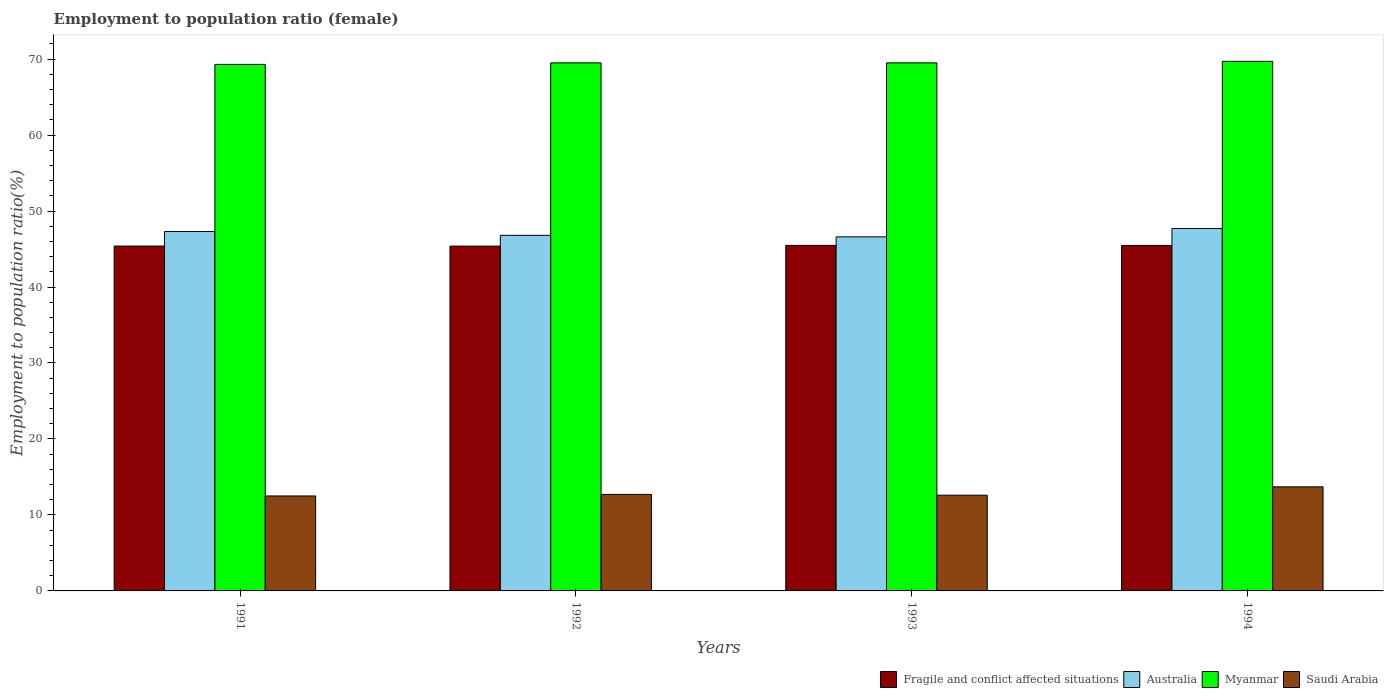How many different coloured bars are there?
Keep it short and to the point. 4. How many bars are there on the 2nd tick from the right?
Provide a succinct answer. 4. What is the label of the 2nd group of bars from the left?
Offer a terse response. 1992. What is the employment to population ratio in Australia in 1992?
Provide a succinct answer. 46.8. Across all years, what is the maximum employment to population ratio in Fragile and conflict affected situations?
Make the answer very short. 45.48. In which year was the employment to population ratio in Myanmar maximum?
Ensure brevity in your answer.  1994. In which year was the employment to population ratio in Fragile and conflict affected situations minimum?
Offer a very short reply. 1992. What is the total employment to population ratio in Australia in the graph?
Keep it short and to the point. 188.4. What is the difference between the employment to population ratio in Australia in 1991 and that in 1994?
Your response must be concise. -0.4. What is the difference between the employment to population ratio in Fragile and conflict affected situations in 1991 and the employment to population ratio in Saudi Arabia in 1994?
Your answer should be very brief. 31.69. What is the average employment to population ratio in Fragile and conflict affected situations per year?
Your answer should be very brief. 45.43. In the year 1992, what is the difference between the employment to population ratio in Myanmar and employment to population ratio in Australia?
Offer a terse response. 22.7. What is the ratio of the employment to population ratio in Australia in 1992 to that in 1993?
Offer a very short reply. 1. What is the difference between the highest and the second highest employment to population ratio in Australia?
Keep it short and to the point. 0.4. What is the difference between the highest and the lowest employment to population ratio in Saudi Arabia?
Provide a succinct answer. 1.2. Is the sum of the employment to population ratio in Saudi Arabia in 1993 and 1994 greater than the maximum employment to population ratio in Myanmar across all years?
Your answer should be very brief. No. Is it the case that in every year, the sum of the employment to population ratio in Australia and employment to population ratio in Fragile and conflict affected situations is greater than the sum of employment to population ratio in Saudi Arabia and employment to population ratio in Myanmar?
Make the answer very short. No. What does the 2nd bar from the left in 1991 represents?
Provide a short and direct response. Australia. What does the 2nd bar from the right in 1991 represents?
Your answer should be compact. Myanmar. Are all the bars in the graph horizontal?
Your answer should be very brief. No. Are the values on the major ticks of Y-axis written in scientific E-notation?
Provide a succinct answer. No. How many legend labels are there?
Your answer should be compact. 4. How are the legend labels stacked?
Make the answer very short. Horizontal. What is the title of the graph?
Your answer should be compact. Employment to population ratio (female). What is the label or title of the Y-axis?
Offer a very short reply. Employment to population ratio(%). What is the Employment to population ratio(%) of Fragile and conflict affected situations in 1991?
Offer a terse response. 45.39. What is the Employment to population ratio(%) of Australia in 1991?
Give a very brief answer. 47.3. What is the Employment to population ratio(%) in Myanmar in 1991?
Give a very brief answer. 69.3. What is the Employment to population ratio(%) in Fragile and conflict affected situations in 1992?
Offer a terse response. 45.38. What is the Employment to population ratio(%) in Australia in 1992?
Ensure brevity in your answer.  46.8. What is the Employment to population ratio(%) in Myanmar in 1992?
Make the answer very short. 69.5. What is the Employment to population ratio(%) of Saudi Arabia in 1992?
Your answer should be very brief. 12.7. What is the Employment to population ratio(%) in Fragile and conflict affected situations in 1993?
Your answer should be compact. 45.48. What is the Employment to population ratio(%) in Australia in 1993?
Give a very brief answer. 46.6. What is the Employment to population ratio(%) in Myanmar in 1993?
Your response must be concise. 69.5. What is the Employment to population ratio(%) of Saudi Arabia in 1993?
Make the answer very short. 12.6. What is the Employment to population ratio(%) of Fragile and conflict affected situations in 1994?
Make the answer very short. 45.47. What is the Employment to population ratio(%) of Australia in 1994?
Ensure brevity in your answer.  47.7. What is the Employment to population ratio(%) in Myanmar in 1994?
Your answer should be compact. 69.7. What is the Employment to population ratio(%) of Saudi Arabia in 1994?
Your answer should be compact. 13.7. Across all years, what is the maximum Employment to population ratio(%) in Fragile and conflict affected situations?
Keep it short and to the point. 45.48. Across all years, what is the maximum Employment to population ratio(%) in Australia?
Provide a short and direct response. 47.7. Across all years, what is the maximum Employment to population ratio(%) in Myanmar?
Ensure brevity in your answer.  69.7. Across all years, what is the maximum Employment to population ratio(%) of Saudi Arabia?
Give a very brief answer. 13.7. Across all years, what is the minimum Employment to population ratio(%) of Fragile and conflict affected situations?
Offer a very short reply. 45.38. Across all years, what is the minimum Employment to population ratio(%) of Australia?
Offer a terse response. 46.6. Across all years, what is the minimum Employment to population ratio(%) of Myanmar?
Your answer should be very brief. 69.3. What is the total Employment to population ratio(%) in Fragile and conflict affected situations in the graph?
Provide a succinct answer. 181.72. What is the total Employment to population ratio(%) of Australia in the graph?
Ensure brevity in your answer.  188.4. What is the total Employment to population ratio(%) in Myanmar in the graph?
Make the answer very short. 278. What is the total Employment to population ratio(%) in Saudi Arabia in the graph?
Offer a terse response. 51.5. What is the difference between the Employment to population ratio(%) in Fragile and conflict affected situations in 1991 and that in 1992?
Make the answer very short. 0.01. What is the difference between the Employment to population ratio(%) of Saudi Arabia in 1991 and that in 1992?
Keep it short and to the point. -0.2. What is the difference between the Employment to population ratio(%) in Fragile and conflict affected situations in 1991 and that in 1993?
Make the answer very short. -0.08. What is the difference between the Employment to population ratio(%) in Myanmar in 1991 and that in 1993?
Your answer should be very brief. -0.2. What is the difference between the Employment to population ratio(%) of Fragile and conflict affected situations in 1991 and that in 1994?
Offer a terse response. -0.08. What is the difference between the Employment to population ratio(%) in Australia in 1991 and that in 1994?
Offer a very short reply. -0.4. What is the difference between the Employment to population ratio(%) of Myanmar in 1991 and that in 1994?
Give a very brief answer. -0.4. What is the difference between the Employment to population ratio(%) in Fragile and conflict affected situations in 1992 and that in 1993?
Provide a succinct answer. -0.09. What is the difference between the Employment to population ratio(%) in Australia in 1992 and that in 1993?
Ensure brevity in your answer.  0.2. What is the difference between the Employment to population ratio(%) in Saudi Arabia in 1992 and that in 1993?
Your response must be concise. 0.1. What is the difference between the Employment to population ratio(%) of Fragile and conflict affected situations in 1992 and that in 1994?
Make the answer very short. -0.09. What is the difference between the Employment to population ratio(%) of Australia in 1992 and that in 1994?
Make the answer very short. -0.9. What is the difference between the Employment to population ratio(%) in Myanmar in 1992 and that in 1994?
Your answer should be very brief. -0.2. What is the difference between the Employment to population ratio(%) of Saudi Arabia in 1992 and that in 1994?
Offer a very short reply. -1. What is the difference between the Employment to population ratio(%) in Fragile and conflict affected situations in 1993 and that in 1994?
Provide a succinct answer. 0.01. What is the difference between the Employment to population ratio(%) of Australia in 1993 and that in 1994?
Offer a very short reply. -1.1. What is the difference between the Employment to population ratio(%) of Fragile and conflict affected situations in 1991 and the Employment to population ratio(%) of Australia in 1992?
Make the answer very short. -1.41. What is the difference between the Employment to population ratio(%) of Fragile and conflict affected situations in 1991 and the Employment to population ratio(%) of Myanmar in 1992?
Make the answer very short. -24.11. What is the difference between the Employment to population ratio(%) of Fragile and conflict affected situations in 1991 and the Employment to population ratio(%) of Saudi Arabia in 1992?
Your response must be concise. 32.69. What is the difference between the Employment to population ratio(%) of Australia in 1991 and the Employment to population ratio(%) of Myanmar in 1992?
Provide a succinct answer. -22.2. What is the difference between the Employment to population ratio(%) of Australia in 1991 and the Employment to population ratio(%) of Saudi Arabia in 1992?
Provide a succinct answer. 34.6. What is the difference between the Employment to population ratio(%) of Myanmar in 1991 and the Employment to population ratio(%) of Saudi Arabia in 1992?
Provide a succinct answer. 56.6. What is the difference between the Employment to population ratio(%) of Fragile and conflict affected situations in 1991 and the Employment to population ratio(%) of Australia in 1993?
Provide a short and direct response. -1.21. What is the difference between the Employment to population ratio(%) of Fragile and conflict affected situations in 1991 and the Employment to population ratio(%) of Myanmar in 1993?
Offer a terse response. -24.11. What is the difference between the Employment to population ratio(%) in Fragile and conflict affected situations in 1991 and the Employment to population ratio(%) in Saudi Arabia in 1993?
Your answer should be compact. 32.79. What is the difference between the Employment to population ratio(%) in Australia in 1991 and the Employment to population ratio(%) in Myanmar in 1993?
Your answer should be compact. -22.2. What is the difference between the Employment to population ratio(%) of Australia in 1991 and the Employment to population ratio(%) of Saudi Arabia in 1993?
Offer a terse response. 34.7. What is the difference between the Employment to population ratio(%) in Myanmar in 1991 and the Employment to population ratio(%) in Saudi Arabia in 1993?
Your answer should be very brief. 56.7. What is the difference between the Employment to population ratio(%) in Fragile and conflict affected situations in 1991 and the Employment to population ratio(%) in Australia in 1994?
Your answer should be compact. -2.31. What is the difference between the Employment to population ratio(%) of Fragile and conflict affected situations in 1991 and the Employment to population ratio(%) of Myanmar in 1994?
Make the answer very short. -24.31. What is the difference between the Employment to population ratio(%) in Fragile and conflict affected situations in 1991 and the Employment to population ratio(%) in Saudi Arabia in 1994?
Offer a very short reply. 31.69. What is the difference between the Employment to population ratio(%) of Australia in 1991 and the Employment to population ratio(%) of Myanmar in 1994?
Provide a succinct answer. -22.4. What is the difference between the Employment to population ratio(%) in Australia in 1991 and the Employment to population ratio(%) in Saudi Arabia in 1994?
Keep it short and to the point. 33.6. What is the difference between the Employment to population ratio(%) of Myanmar in 1991 and the Employment to population ratio(%) of Saudi Arabia in 1994?
Provide a succinct answer. 55.6. What is the difference between the Employment to population ratio(%) in Fragile and conflict affected situations in 1992 and the Employment to population ratio(%) in Australia in 1993?
Provide a short and direct response. -1.22. What is the difference between the Employment to population ratio(%) in Fragile and conflict affected situations in 1992 and the Employment to population ratio(%) in Myanmar in 1993?
Give a very brief answer. -24.12. What is the difference between the Employment to population ratio(%) in Fragile and conflict affected situations in 1992 and the Employment to population ratio(%) in Saudi Arabia in 1993?
Your answer should be very brief. 32.78. What is the difference between the Employment to population ratio(%) of Australia in 1992 and the Employment to population ratio(%) of Myanmar in 1993?
Make the answer very short. -22.7. What is the difference between the Employment to population ratio(%) in Australia in 1992 and the Employment to population ratio(%) in Saudi Arabia in 1993?
Give a very brief answer. 34.2. What is the difference between the Employment to population ratio(%) in Myanmar in 1992 and the Employment to population ratio(%) in Saudi Arabia in 1993?
Provide a succinct answer. 56.9. What is the difference between the Employment to population ratio(%) of Fragile and conflict affected situations in 1992 and the Employment to population ratio(%) of Australia in 1994?
Make the answer very short. -2.32. What is the difference between the Employment to population ratio(%) in Fragile and conflict affected situations in 1992 and the Employment to population ratio(%) in Myanmar in 1994?
Provide a succinct answer. -24.32. What is the difference between the Employment to population ratio(%) of Fragile and conflict affected situations in 1992 and the Employment to population ratio(%) of Saudi Arabia in 1994?
Give a very brief answer. 31.68. What is the difference between the Employment to population ratio(%) in Australia in 1992 and the Employment to population ratio(%) in Myanmar in 1994?
Your answer should be very brief. -22.9. What is the difference between the Employment to population ratio(%) in Australia in 1992 and the Employment to population ratio(%) in Saudi Arabia in 1994?
Keep it short and to the point. 33.1. What is the difference between the Employment to population ratio(%) in Myanmar in 1992 and the Employment to population ratio(%) in Saudi Arabia in 1994?
Give a very brief answer. 55.8. What is the difference between the Employment to population ratio(%) of Fragile and conflict affected situations in 1993 and the Employment to population ratio(%) of Australia in 1994?
Offer a very short reply. -2.23. What is the difference between the Employment to population ratio(%) of Fragile and conflict affected situations in 1993 and the Employment to population ratio(%) of Myanmar in 1994?
Offer a terse response. -24.23. What is the difference between the Employment to population ratio(%) of Fragile and conflict affected situations in 1993 and the Employment to population ratio(%) of Saudi Arabia in 1994?
Your response must be concise. 31.77. What is the difference between the Employment to population ratio(%) of Australia in 1993 and the Employment to population ratio(%) of Myanmar in 1994?
Provide a succinct answer. -23.1. What is the difference between the Employment to population ratio(%) in Australia in 1993 and the Employment to population ratio(%) in Saudi Arabia in 1994?
Your answer should be compact. 32.9. What is the difference between the Employment to population ratio(%) in Myanmar in 1993 and the Employment to population ratio(%) in Saudi Arabia in 1994?
Make the answer very short. 55.8. What is the average Employment to population ratio(%) of Fragile and conflict affected situations per year?
Provide a succinct answer. 45.43. What is the average Employment to population ratio(%) of Australia per year?
Keep it short and to the point. 47.1. What is the average Employment to population ratio(%) in Myanmar per year?
Your answer should be very brief. 69.5. What is the average Employment to population ratio(%) in Saudi Arabia per year?
Offer a very short reply. 12.88. In the year 1991, what is the difference between the Employment to population ratio(%) of Fragile and conflict affected situations and Employment to population ratio(%) of Australia?
Your response must be concise. -1.91. In the year 1991, what is the difference between the Employment to population ratio(%) in Fragile and conflict affected situations and Employment to population ratio(%) in Myanmar?
Offer a very short reply. -23.91. In the year 1991, what is the difference between the Employment to population ratio(%) of Fragile and conflict affected situations and Employment to population ratio(%) of Saudi Arabia?
Offer a terse response. 32.89. In the year 1991, what is the difference between the Employment to population ratio(%) in Australia and Employment to population ratio(%) in Myanmar?
Your answer should be compact. -22. In the year 1991, what is the difference between the Employment to population ratio(%) in Australia and Employment to population ratio(%) in Saudi Arabia?
Your response must be concise. 34.8. In the year 1991, what is the difference between the Employment to population ratio(%) of Myanmar and Employment to population ratio(%) of Saudi Arabia?
Your answer should be compact. 56.8. In the year 1992, what is the difference between the Employment to population ratio(%) in Fragile and conflict affected situations and Employment to population ratio(%) in Australia?
Your response must be concise. -1.42. In the year 1992, what is the difference between the Employment to population ratio(%) of Fragile and conflict affected situations and Employment to population ratio(%) of Myanmar?
Keep it short and to the point. -24.12. In the year 1992, what is the difference between the Employment to population ratio(%) of Fragile and conflict affected situations and Employment to population ratio(%) of Saudi Arabia?
Provide a succinct answer. 32.68. In the year 1992, what is the difference between the Employment to population ratio(%) of Australia and Employment to population ratio(%) of Myanmar?
Your answer should be compact. -22.7. In the year 1992, what is the difference between the Employment to population ratio(%) in Australia and Employment to population ratio(%) in Saudi Arabia?
Give a very brief answer. 34.1. In the year 1992, what is the difference between the Employment to population ratio(%) in Myanmar and Employment to population ratio(%) in Saudi Arabia?
Offer a terse response. 56.8. In the year 1993, what is the difference between the Employment to population ratio(%) in Fragile and conflict affected situations and Employment to population ratio(%) in Australia?
Provide a short and direct response. -1.12. In the year 1993, what is the difference between the Employment to population ratio(%) in Fragile and conflict affected situations and Employment to population ratio(%) in Myanmar?
Offer a terse response. -24.02. In the year 1993, what is the difference between the Employment to population ratio(%) of Fragile and conflict affected situations and Employment to population ratio(%) of Saudi Arabia?
Give a very brief answer. 32.88. In the year 1993, what is the difference between the Employment to population ratio(%) in Australia and Employment to population ratio(%) in Myanmar?
Your answer should be very brief. -22.9. In the year 1993, what is the difference between the Employment to population ratio(%) of Australia and Employment to population ratio(%) of Saudi Arabia?
Offer a very short reply. 34. In the year 1993, what is the difference between the Employment to population ratio(%) of Myanmar and Employment to population ratio(%) of Saudi Arabia?
Offer a very short reply. 56.9. In the year 1994, what is the difference between the Employment to population ratio(%) in Fragile and conflict affected situations and Employment to population ratio(%) in Australia?
Your answer should be very brief. -2.23. In the year 1994, what is the difference between the Employment to population ratio(%) in Fragile and conflict affected situations and Employment to population ratio(%) in Myanmar?
Your answer should be very brief. -24.23. In the year 1994, what is the difference between the Employment to population ratio(%) of Fragile and conflict affected situations and Employment to population ratio(%) of Saudi Arabia?
Keep it short and to the point. 31.77. In the year 1994, what is the difference between the Employment to population ratio(%) of Australia and Employment to population ratio(%) of Myanmar?
Offer a terse response. -22. In the year 1994, what is the difference between the Employment to population ratio(%) in Myanmar and Employment to population ratio(%) in Saudi Arabia?
Offer a terse response. 56. What is the ratio of the Employment to population ratio(%) in Fragile and conflict affected situations in 1991 to that in 1992?
Keep it short and to the point. 1. What is the ratio of the Employment to population ratio(%) of Australia in 1991 to that in 1992?
Your answer should be very brief. 1.01. What is the ratio of the Employment to population ratio(%) of Saudi Arabia in 1991 to that in 1992?
Offer a very short reply. 0.98. What is the ratio of the Employment to population ratio(%) in Fragile and conflict affected situations in 1991 to that in 1993?
Ensure brevity in your answer.  1. What is the ratio of the Employment to population ratio(%) in Saudi Arabia in 1991 to that in 1993?
Give a very brief answer. 0.99. What is the ratio of the Employment to population ratio(%) of Fragile and conflict affected situations in 1991 to that in 1994?
Keep it short and to the point. 1. What is the ratio of the Employment to population ratio(%) of Australia in 1991 to that in 1994?
Your answer should be very brief. 0.99. What is the ratio of the Employment to population ratio(%) of Saudi Arabia in 1991 to that in 1994?
Your response must be concise. 0.91. What is the ratio of the Employment to population ratio(%) of Saudi Arabia in 1992 to that in 1993?
Make the answer very short. 1.01. What is the ratio of the Employment to population ratio(%) of Fragile and conflict affected situations in 1992 to that in 1994?
Provide a succinct answer. 1. What is the ratio of the Employment to population ratio(%) of Australia in 1992 to that in 1994?
Make the answer very short. 0.98. What is the ratio of the Employment to population ratio(%) in Myanmar in 1992 to that in 1994?
Keep it short and to the point. 1. What is the ratio of the Employment to population ratio(%) of Saudi Arabia in 1992 to that in 1994?
Ensure brevity in your answer.  0.93. What is the ratio of the Employment to population ratio(%) of Australia in 1993 to that in 1994?
Provide a succinct answer. 0.98. What is the ratio of the Employment to population ratio(%) of Myanmar in 1993 to that in 1994?
Provide a succinct answer. 1. What is the ratio of the Employment to population ratio(%) in Saudi Arabia in 1993 to that in 1994?
Offer a terse response. 0.92. What is the difference between the highest and the second highest Employment to population ratio(%) of Fragile and conflict affected situations?
Ensure brevity in your answer.  0.01. What is the difference between the highest and the lowest Employment to population ratio(%) in Fragile and conflict affected situations?
Offer a very short reply. 0.09. 